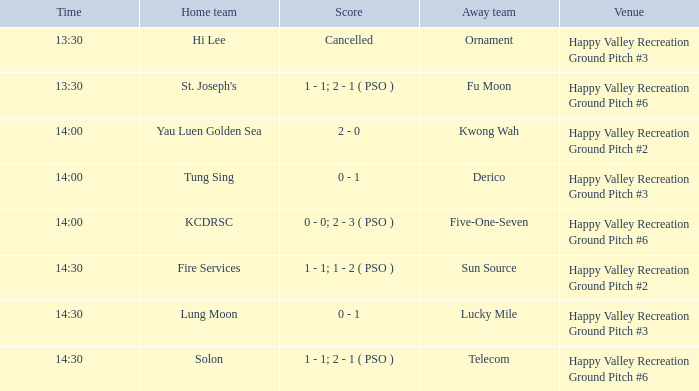What is the away team when solon was the home team? Telecom. 